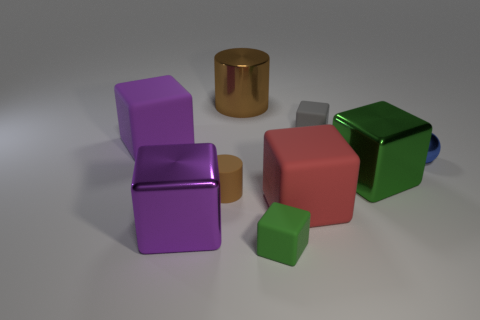Subtract all big red matte blocks. How many blocks are left? 5 Subtract all gray cubes. How many cubes are left? 5 Subtract 1 red blocks. How many objects are left? 8 Subtract all cylinders. How many objects are left? 7 Subtract 6 blocks. How many blocks are left? 0 Subtract all purple spheres. Subtract all purple cubes. How many spheres are left? 1 Subtract all cyan spheres. How many yellow blocks are left? 0 Subtract all metallic balls. Subtract all small brown rubber cylinders. How many objects are left? 7 Add 7 large purple matte cubes. How many large purple matte cubes are left? 8 Add 6 big brown metal objects. How many big brown metal objects exist? 7 